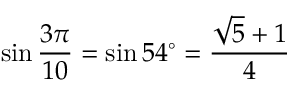Convert formula to latex. <formula><loc_0><loc_0><loc_500><loc_500>\sin { \frac { 3 \pi } { 1 0 } } = \sin 5 4 ^ { \circ } = { \frac { { \sqrt { 5 } } + 1 } { 4 } } \,</formula> 